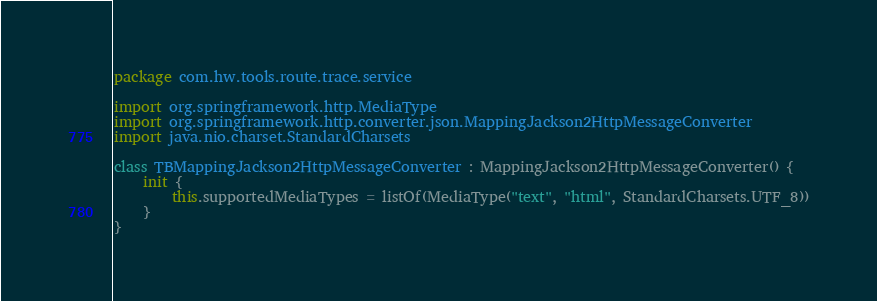Convert code to text. <code><loc_0><loc_0><loc_500><loc_500><_Kotlin_>package com.hw.tools.route.trace.service

import org.springframework.http.MediaType
import org.springframework.http.converter.json.MappingJackson2HttpMessageConverter
import java.nio.charset.StandardCharsets

class TBMappingJackson2HttpMessageConverter : MappingJackson2HttpMessageConverter() {
    init {
        this.supportedMediaTypes = listOf(MediaType("text", "html", StandardCharsets.UTF_8))
    }
}</code> 